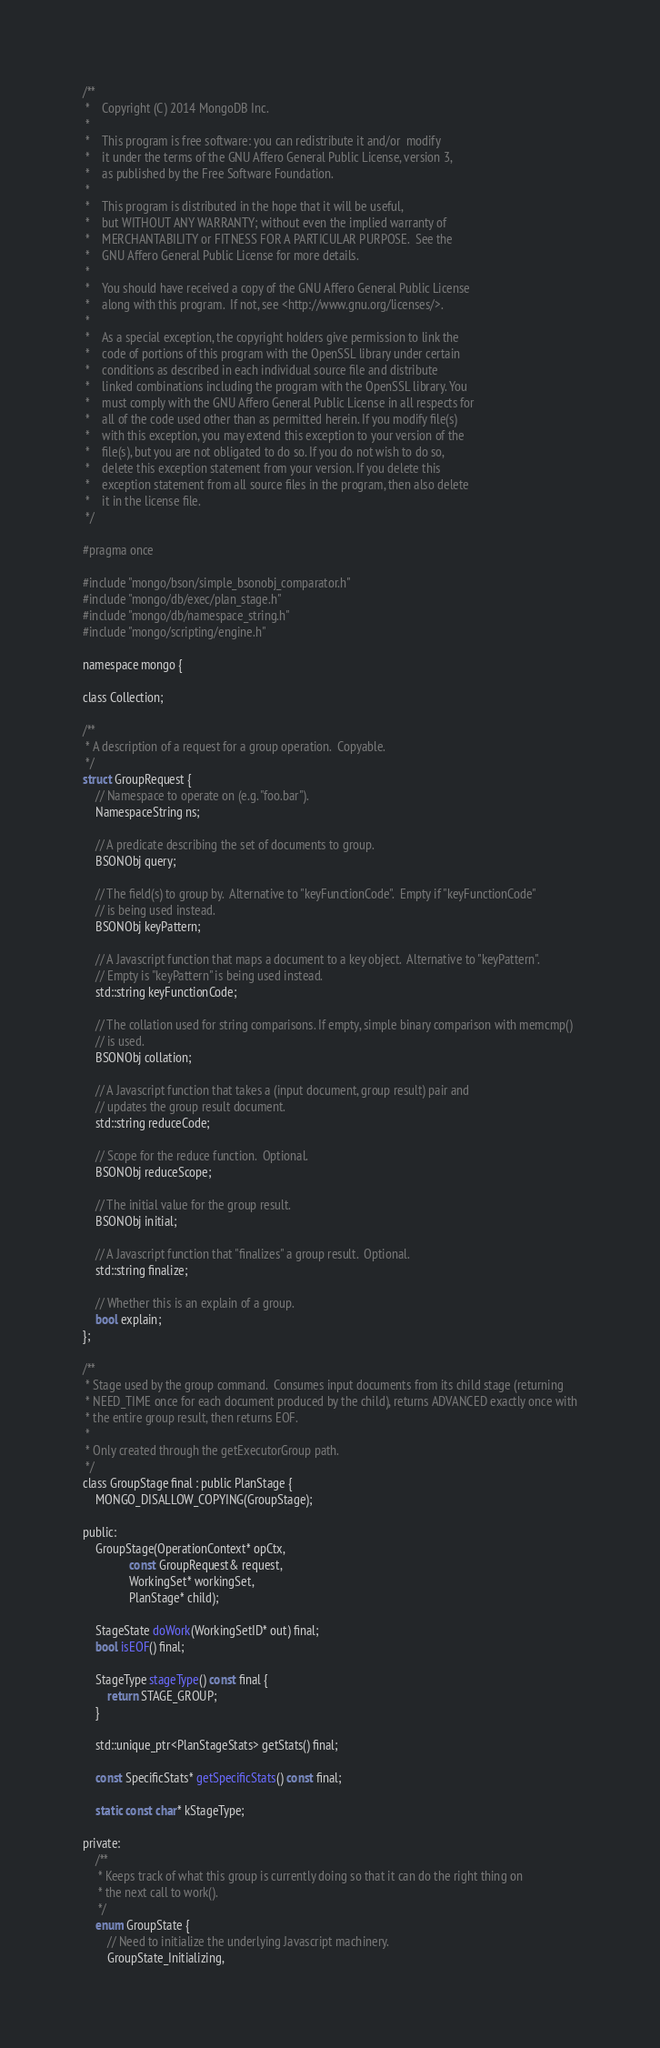<code> <loc_0><loc_0><loc_500><loc_500><_C_>/**
 *    Copyright (C) 2014 MongoDB Inc.
 *
 *    This program is free software: you can redistribute it and/or  modify
 *    it under the terms of the GNU Affero General Public License, version 3,
 *    as published by the Free Software Foundation.
 *
 *    This program is distributed in the hope that it will be useful,
 *    but WITHOUT ANY WARRANTY; without even the implied warranty of
 *    MERCHANTABILITY or FITNESS FOR A PARTICULAR PURPOSE.  See the
 *    GNU Affero General Public License for more details.
 *
 *    You should have received a copy of the GNU Affero General Public License
 *    along with this program.  If not, see <http://www.gnu.org/licenses/>.
 *
 *    As a special exception, the copyright holders give permission to link the
 *    code of portions of this program with the OpenSSL library under certain
 *    conditions as described in each individual source file and distribute
 *    linked combinations including the program with the OpenSSL library. You
 *    must comply with the GNU Affero General Public License in all respects for
 *    all of the code used other than as permitted herein. If you modify file(s)
 *    with this exception, you may extend this exception to your version of the
 *    file(s), but you are not obligated to do so. If you do not wish to do so,
 *    delete this exception statement from your version. If you delete this
 *    exception statement from all source files in the program, then also delete
 *    it in the license file.
 */

#pragma once

#include "mongo/bson/simple_bsonobj_comparator.h"
#include "mongo/db/exec/plan_stage.h"
#include "mongo/db/namespace_string.h"
#include "mongo/scripting/engine.h"

namespace mongo {

class Collection;

/**
 * A description of a request for a group operation.  Copyable.
 */
struct GroupRequest {
    // Namespace to operate on (e.g. "foo.bar").
    NamespaceString ns;

    // A predicate describing the set of documents to group.
    BSONObj query;

    // The field(s) to group by.  Alternative to "keyFunctionCode".  Empty if "keyFunctionCode"
    // is being used instead.
    BSONObj keyPattern;

    // A Javascript function that maps a document to a key object.  Alternative to "keyPattern".
    // Empty is "keyPattern" is being used instead.
    std::string keyFunctionCode;

    // The collation used for string comparisons. If empty, simple binary comparison with memcmp()
    // is used.
    BSONObj collation;

    // A Javascript function that takes a (input document, group result) pair and
    // updates the group result document.
    std::string reduceCode;

    // Scope for the reduce function.  Optional.
    BSONObj reduceScope;

    // The initial value for the group result.
    BSONObj initial;

    // A Javascript function that "finalizes" a group result.  Optional.
    std::string finalize;

    // Whether this is an explain of a group.
    bool explain;
};

/**
 * Stage used by the group command.  Consumes input documents from its child stage (returning
 * NEED_TIME once for each document produced by the child), returns ADVANCED exactly once with
 * the entire group result, then returns EOF.
 *
 * Only created through the getExecutorGroup path.
 */
class GroupStage final : public PlanStage {
    MONGO_DISALLOW_COPYING(GroupStage);

public:
    GroupStage(OperationContext* opCtx,
               const GroupRequest& request,
               WorkingSet* workingSet,
               PlanStage* child);

    StageState doWork(WorkingSetID* out) final;
    bool isEOF() final;

    StageType stageType() const final {
        return STAGE_GROUP;
    }

    std::unique_ptr<PlanStageStats> getStats() final;

    const SpecificStats* getSpecificStats() const final;

    static const char* kStageType;

private:
    /**
     * Keeps track of what this group is currently doing so that it can do the right thing on
     * the next call to work().
     */
    enum GroupState {
        // Need to initialize the underlying Javascript machinery.
        GroupState_Initializing,
</code> 